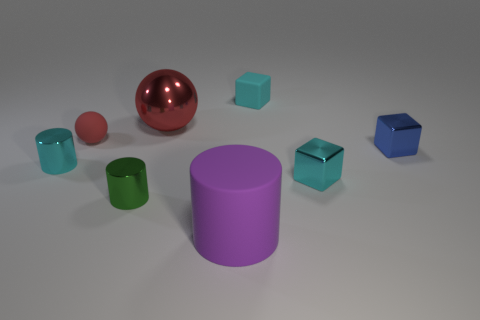Subtract all small cyan shiny cylinders. How many cylinders are left? 2 Subtract all green cylinders. How many cylinders are left? 2 Subtract all spheres. How many objects are left? 6 Add 1 cylinders. How many objects exist? 9 Add 1 cubes. How many cubes exist? 4 Subtract 0 blue cylinders. How many objects are left? 8 Subtract 2 cylinders. How many cylinders are left? 1 Subtract all cyan cylinders. Subtract all green blocks. How many cylinders are left? 2 Subtract all green cubes. How many brown spheres are left? 0 Subtract all tiny balls. Subtract all small blue metal things. How many objects are left? 6 